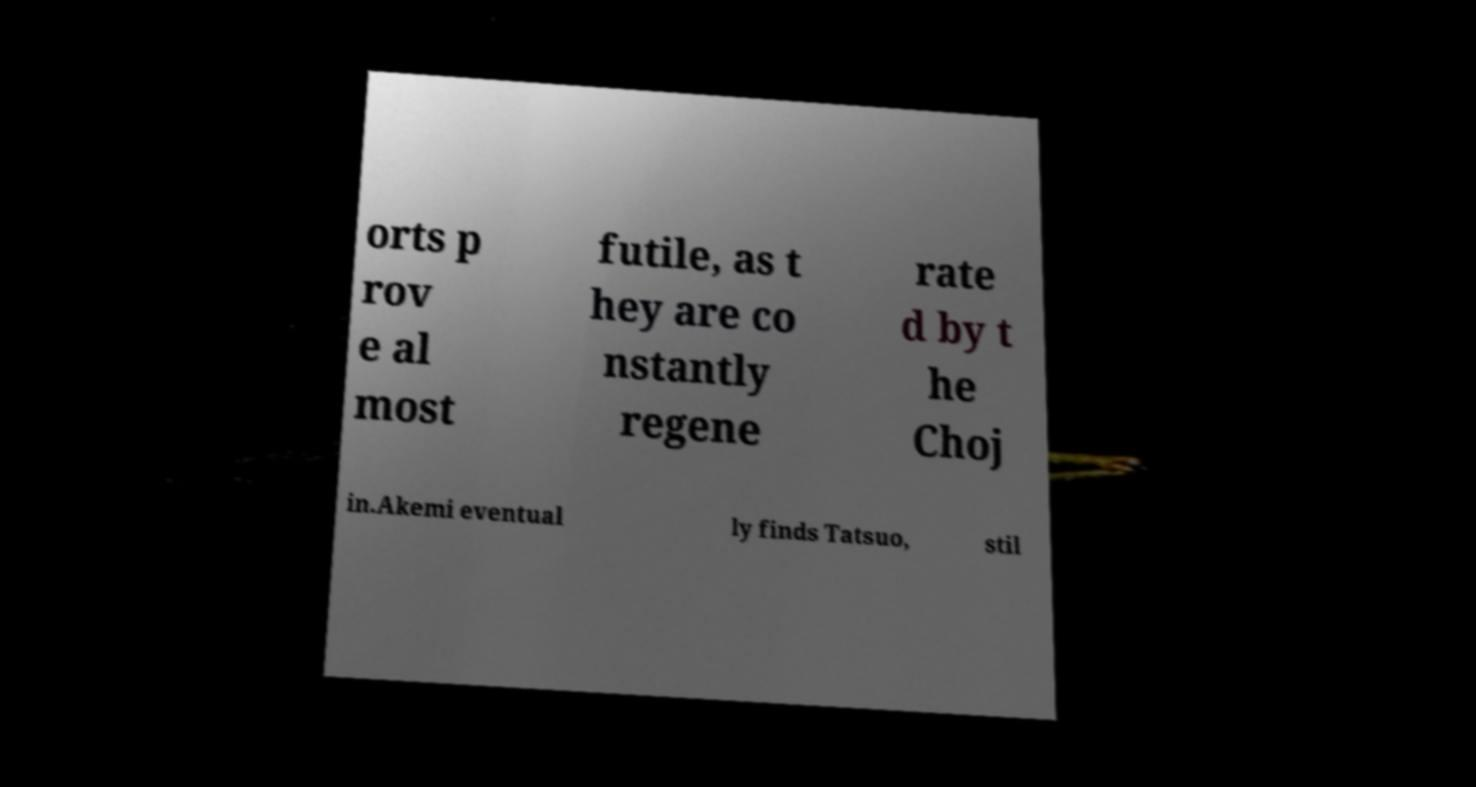Can you read and provide the text displayed in the image?This photo seems to have some interesting text. Can you extract and type it out for me? orts p rov e al most futile, as t hey are co nstantly regene rate d by t he Choj in.Akemi eventual ly finds Tatsuo, stil 